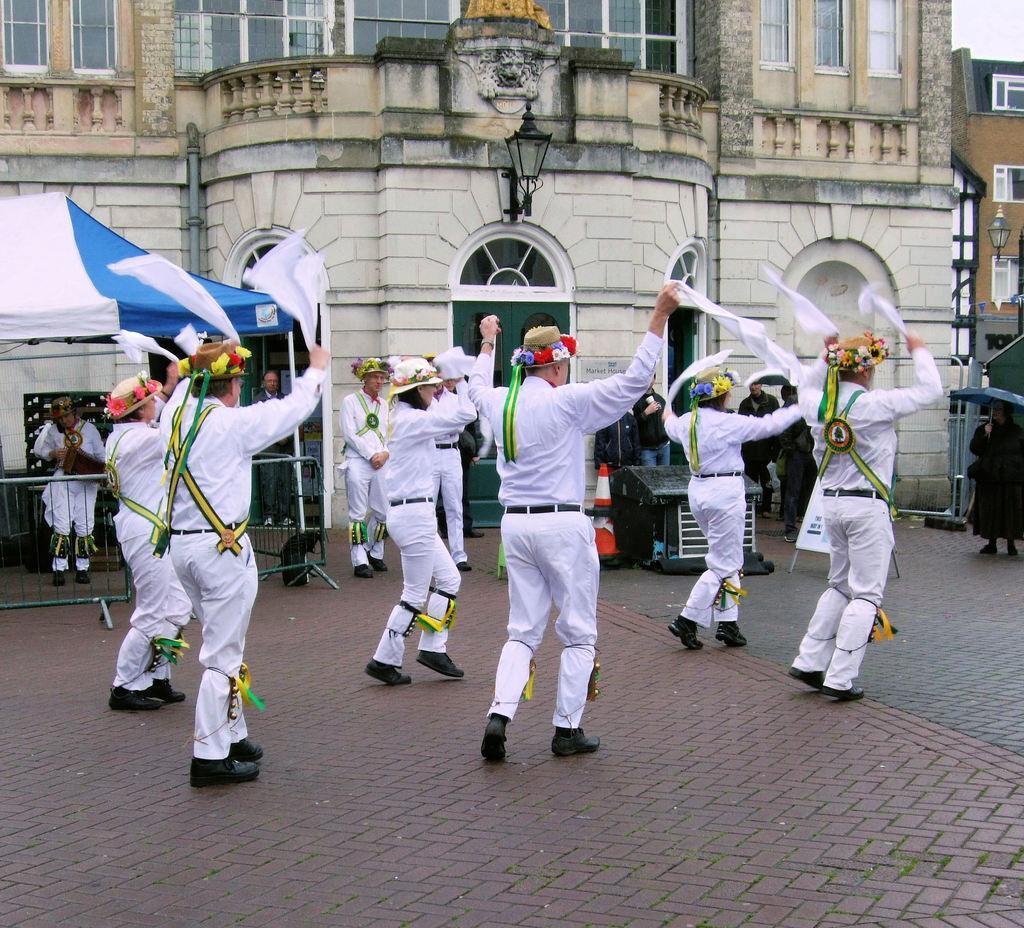How would you summarize this image in a sentence or two? In the middle of the image few people are walking and holding some clothes. Behind them few people are standing and watching and few people are holding some umbrellas and there is a tent. Behind the text there is a building, on the building there is a light. 